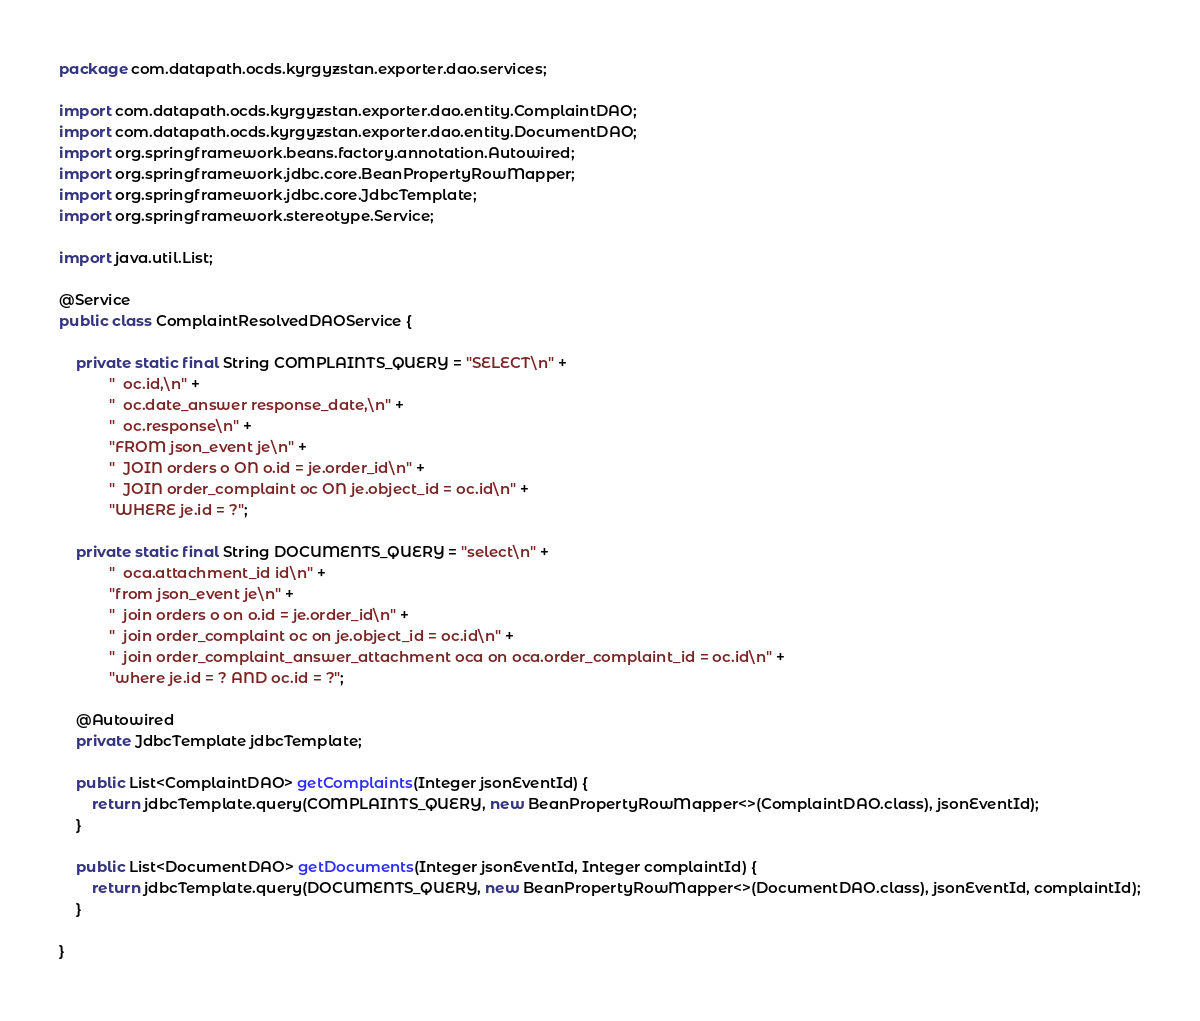<code> <loc_0><loc_0><loc_500><loc_500><_Java_>package com.datapath.ocds.kyrgyzstan.exporter.dao.services;

import com.datapath.ocds.kyrgyzstan.exporter.dao.entity.ComplaintDAO;
import com.datapath.ocds.kyrgyzstan.exporter.dao.entity.DocumentDAO;
import org.springframework.beans.factory.annotation.Autowired;
import org.springframework.jdbc.core.BeanPropertyRowMapper;
import org.springframework.jdbc.core.JdbcTemplate;
import org.springframework.stereotype.Service;

import java.util.List;

@Service
public class ComplaintResolvedDAOService {

    private static final String COMPLAINTS_QUERY = "SELECT\n" +
            "  oc.id,\n" +
            "  oc.date_answer response_date,\n" +
            "  oc.response\n" +
            "FROM json_event je\n" +
            "  JOIN orders o ON o.id = je.order_id\n" +
            "  JOIN order_complaint oc ON je.object_id = oc.id\n" +
            "WHERE je.id = ?";

    private static final String DOCUMENTS_QUERY = "select\n" +
            "  oca.attachment_id id\n" +
            "from json_event je\n" +
            "  join orders o on o.id = je.order_id\n" +
            "  join order_complaint oc on je.object_id = oc.id\n" +
            "  join order_complaint_answer_attachment oca on oca.order_complaint_id = oc.id\n" +
            "where je.id = ? AND oc.id = ?";

    @Autowired
    private JdbcTemplate jdbcTemplate;

    public List<ComplaintDAO> getComplaints(Integer jsonEventId) {
        return jdbcTemplate.query(COMPLAINTS_QUERY, new BeanPropertyRowMapper<>(ComplaintDAO.class), jsonEventId);
    }

    public List<DocumentDAO> getDocuments(Integer jsonEventId, Integer complaintId) {
        return jdbcTemplate.query(DOCUMENTS_QUERY, new BeanPropertyRowMapper<>(DocumentDAO.class), jsonEventId, complaintId);
    }

}</code> 